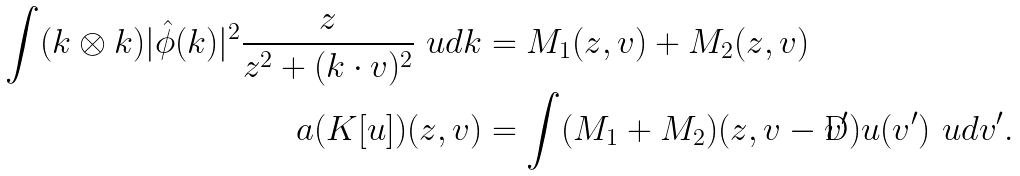<formula> <loc_0><loc_0><loc_500><loc_500>\int ( k \otimes k ) | \hat { \phi } ( k ) | ^ { 2 } \frac { z } { z ^ { 2 } + ( k \cdot v ) ^ { 2 } } \ u d { k } & = M _ { 1 } ( z , v ) + M _ { 2 } ( z , v ) \\ \L a ( K [ u ] ) ( z , v ) & = \int ( M _ { 1 } + M _ { 2 } ) ( z , v - v ^ { \prime } ) u ( v ^ { \prime } ) \ u d { v ^ { \prime } } .</formula> 